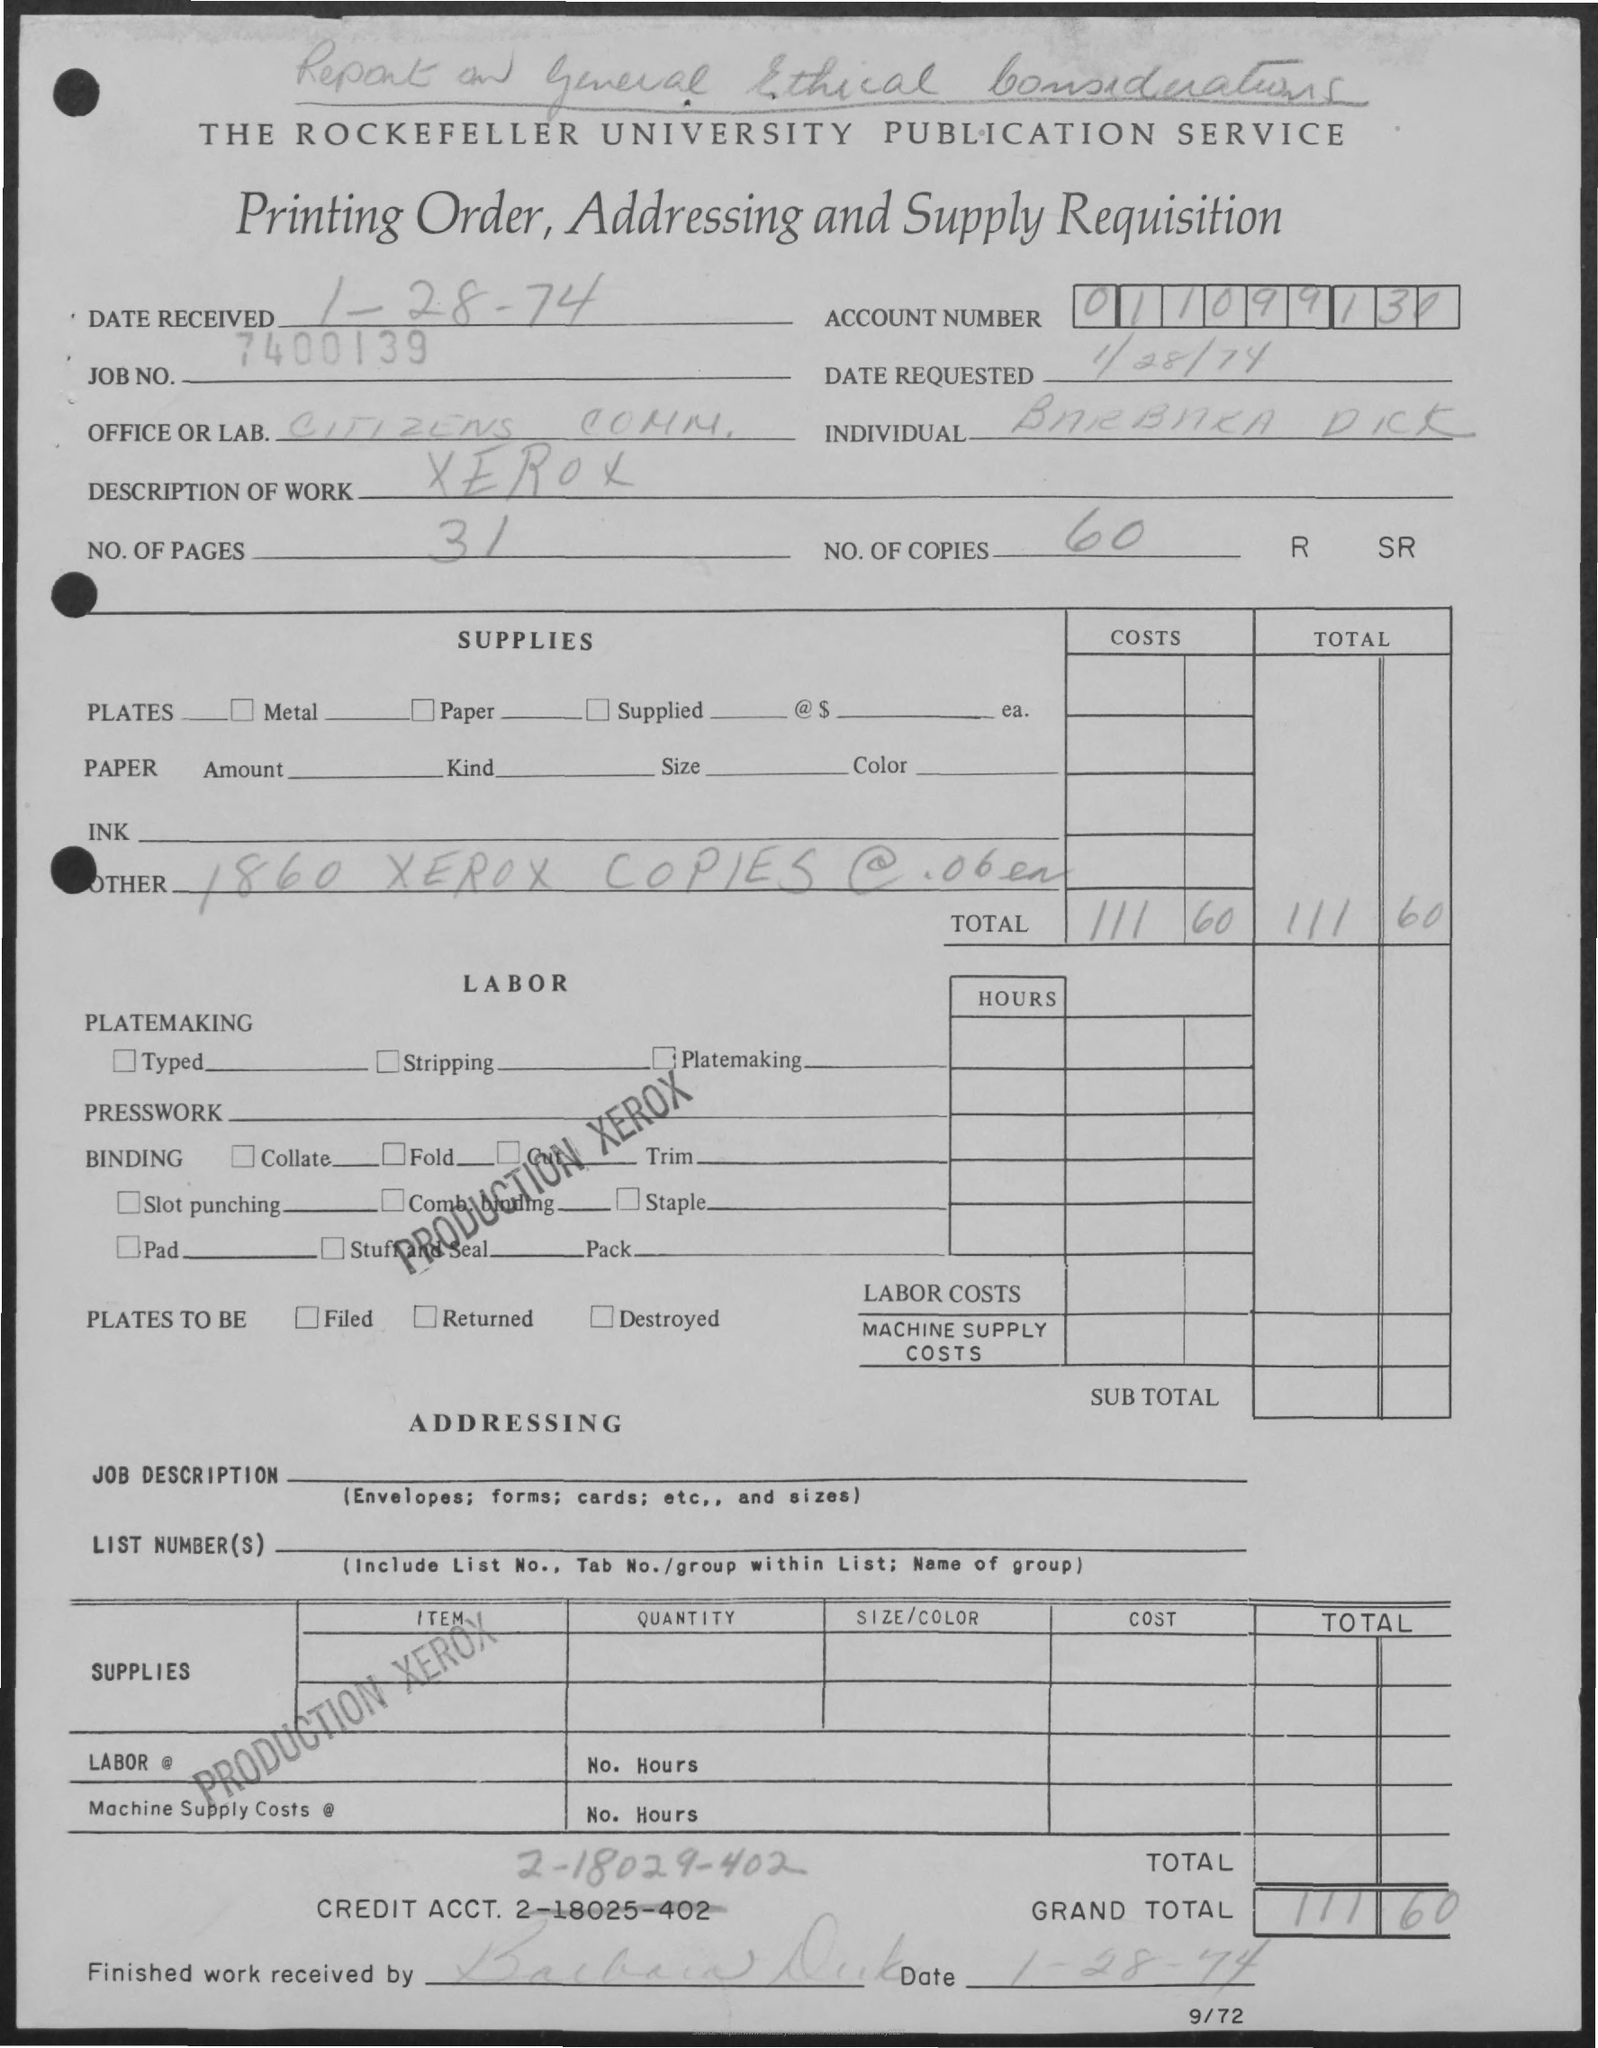What is the Date Received?
Provide a short and direct response. 1-28-74. What is the Job No.?
Your answer should be very brief. 7400139. What is the Account Number?
Give a very brief answer. 011099130. What is the Date Requested?
Make the answer very short. 1/28/74. What is the Description of Work?
Give a very brief answer. Xerox. What are the No. of Pages?
Your response must be concise. 31. Who is the Individual?
Your response must be concise. Barbara Dick. What are the No. of Copies?
Ensure brevity in your answer.  60. What is the Grand Total?
Your response must be concise. 111.60. What is the Credit Acct?
Make the answer very short. 2-18029-402. 